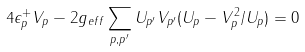Convert formula to latex. <formula><loc_0><loc_0><loc_500><loc_500>4 \epsilon ^ { + } _ { p } V _ { p } - 2 g _ { e f f } \sum _ { p , p ^ { \prime } } U _ { p ^ { \prime } } V _ { p ^ { \prime } } ( U _ { p } - V _ { p } ^ { 2 } / U _ { p } ) = 0</formula> 